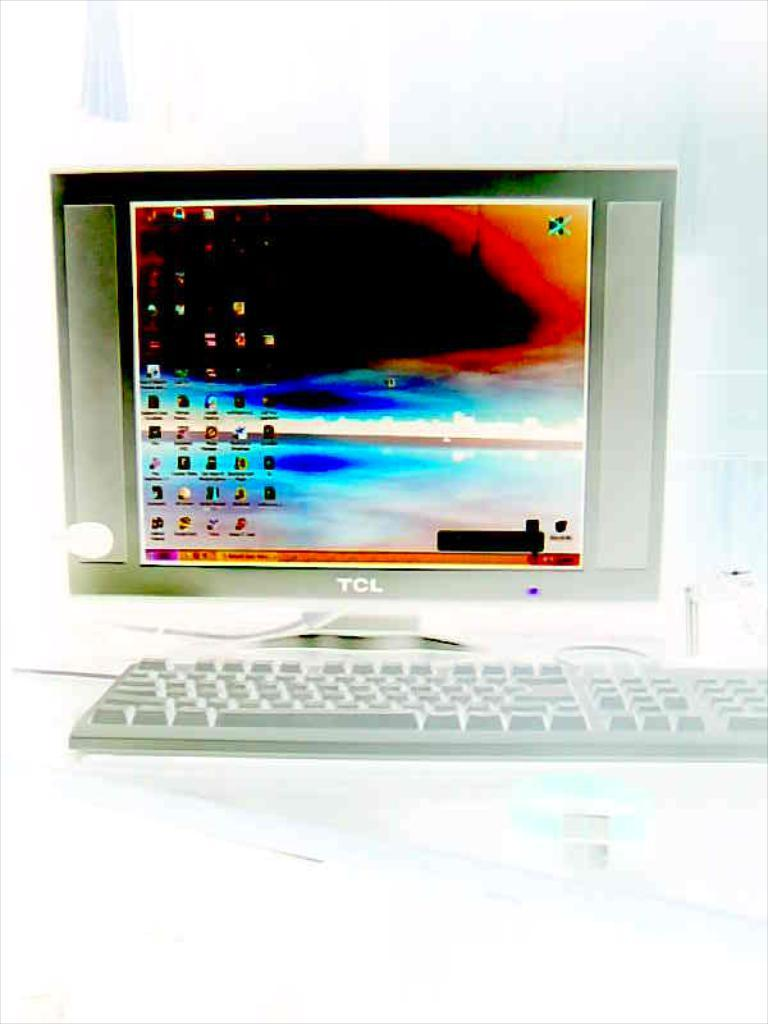<image>
Give a short and clear explanation of the subsequent image. A TCL desktop computer with a colorful background. 